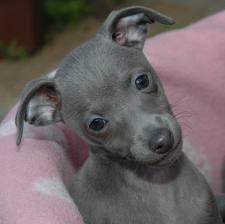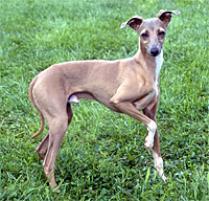The first image is the image on the left, the second image is the image on the right. Evaluate the accuracy of this statement regarding the images: "One of the images contains a dog without visible legs.". Is it true? Answer yes or no. Yes. 